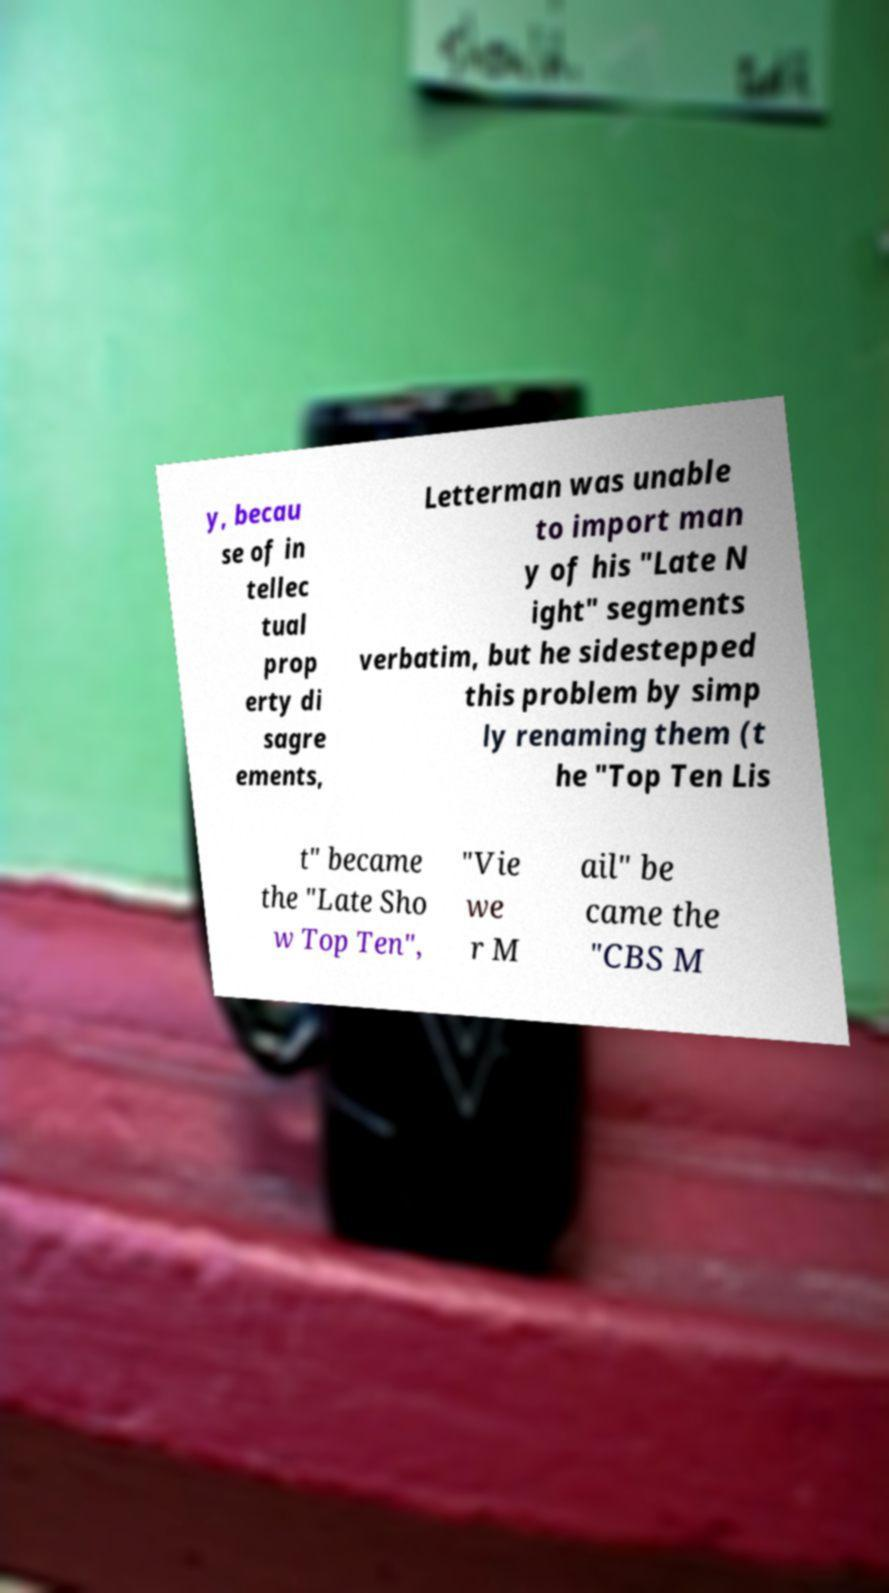For documentation purposes, I need the text within this image transcribed. Could you provide that? y, becau se of in tellec tual prop erty di sagre ements, Letterman was unable to import man y of his "Late N ight" segments verbatim, but he sidestepped this problem by simp ly renaming them (t he "Top Ten Lis t" became the "Late Sho w Top Ten", "Vie we r M ail" be came the "CBS M 